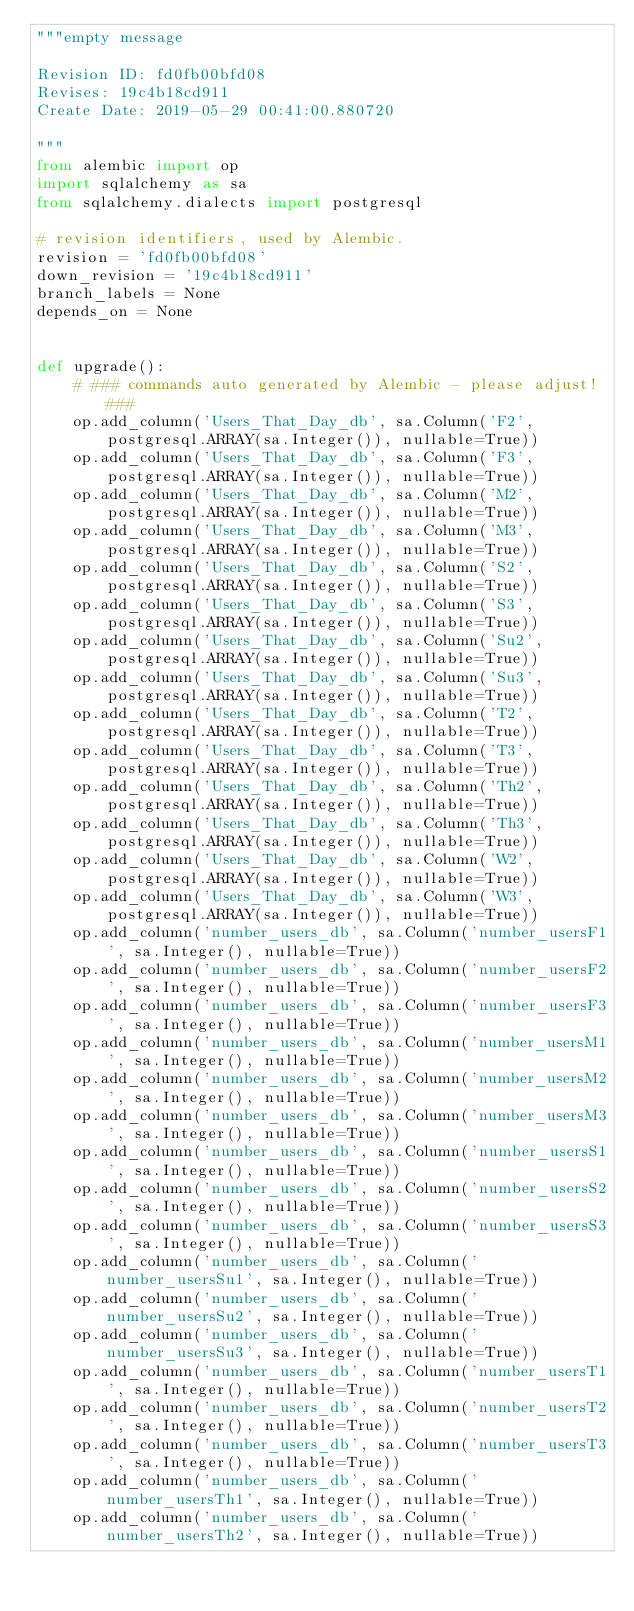<code> <loc_0><loc_0><loc_500><loc_500><_Python_>"""empty message

Revision ID: fd0fb00bfd08
Revises: 19c4b18cd911
Create Date: 2019-05-29 00:41:00.880720

"""
from alembic import op
import sqlalchemy as sa
from sqlalchemy.dialects import postgresql

# revision identifiers, used by Alembic.
revision = 'fd0fb00bfd08'
down_revision = '19c4b18cd911'
branch_labels = None
depends_on = None


def upgrade():
    # ### commands auto generated by Alembic - please adjust! ###
    op.add_column('Users_That_Day_db', sa.Column('F2', postgresql.ARRAY(sa.Integer()), nullable=True))
    op.add_column('Users_That_Day_db', sa.Column('F3', postgresql.ARRAY(sa.Integer()), nullable=True))
    op.add_column('Users_That_Day_db', sa.Column('M2', postgresql.ARRAY(sa.Integer()), nullable=True))
    op.add_column('Users_That_Day_db', sa.Column('M3', postgresql.ARRAY(sa.Integer()), nullable=True))
    op.add_column('Users_That_Day_db', sa.Column('S2', postgresql.ARRAY(sa.Integer()), nullable=True))
    op.add_column('Users_That_Day_db', sa.Column('S3', postgresql.ARRAY(sa.Integer()), nullable=True))
    op.add_column('Users_That_Day_db', sa.Column('Su2', postgresql.ARRAY(sa.Integer()), nullable=True))
    op.add_column('Users_That_Day_db', sa.Column('Su3', postgresql.ARRAY(sa.Integer()), nullable=True))
    op.add_column('Users_That_Day_db', sa.Column('T2', postgresql.ARRAY(sa.Integer()), nullable=True))
    op.add_column('Users_That_Day_db', sa.Column('T3', postgresql.ARRAY(sa.Integer()), nullable=True))
    op.add_column('Users_That_Day_db', sa.Column('Th2', postgresql.ARRAY(sa.Integer()), nullable=True))
    op.add_column('Users_That_Day_db', sa.Column('Th3', postgresql.ARRAY(sa.Integer()), nullable=True))
    op.add_column('Users_That_Day_db', sa.Column('W2', postgresql.ARRAY(sa.Integer()), nullable=True))
    op.add_column('Users_That_Day_db', sa.Column('W3', postgresql.ARRAY(sa.Integer()), nullable=True))
    op.add_column('number_users_db', sa.Column('number_usersF1', sa.Integer(), nullable=True))
    op.add_column('number_users_db', sa.Column('number_usersF2', sa.Integer(), nullable=True))
    op.add_column('number_users_db', sa.Column('number_usersF3', sa.Integer(), nullable=True))
    op.add_column('number_users_db', sa.Column('number_usersM1', sa.Integer(), nullable=True))
    op.add_column('number_users_db', sa.Column('number_usersM2', sa.Integer(), nullable=True))
    op.add_column('number_users_db', sa.Column('number_usersM3', sa.Integer(), nullable=True))
    op.add_column('number_users_db', sa.Column('number_usersS1', sa.Integer(), nullable=True))
    op.add_column('number_users_db', sa.Column('number_usersS2', sa.Integer(), nullable=True))
    op.add_column('number_users_db', sa.Column('number_usersS3', sa.Integer(), nullable=True))
    op.add_column('number_users_db', sa.Column('number_usersSu1', sa.Integer(), nullable=True))
    op.add_column('number_users_db', sa.Column('number_usersSu2', sa.Integer(), nullable=True))
    op.add_column('number_users_db', sa.Column('number_usersSu3', sa.Integer(), nullable=True))
    op.add_column('number_users_db', sa.Column('number_usersT1', sa.Integer(), nullable=True))
    op.add_column('number_users_db', sa.Column('number_usersT2', sa.Integer(), nullable=True))
    op.add_column('number_users_db', sa.Column('number_usersT3', sa.Integer(), nullable=True))
    op.add_column('number_users_db', sa.Column('number_usersTh1', sa.Integer(), nullable=True))
    op.add_column('number_users_db', sa.Column('number_usersTh2', sa.Integer(), nullable=True))</code> 